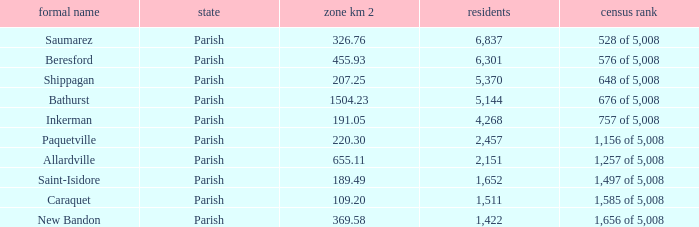What is the Population of the New Bandon Parish with an Area km 2 larger than 326.76? 1422.0. 